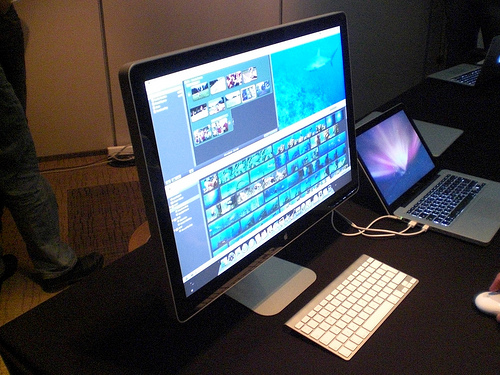<image>
Is there a monitor on the keyboard? No. The monitor is not positioned on the keyboard. They may be near each other, but the monitor is not supported by or resting on top of the keyboard. 